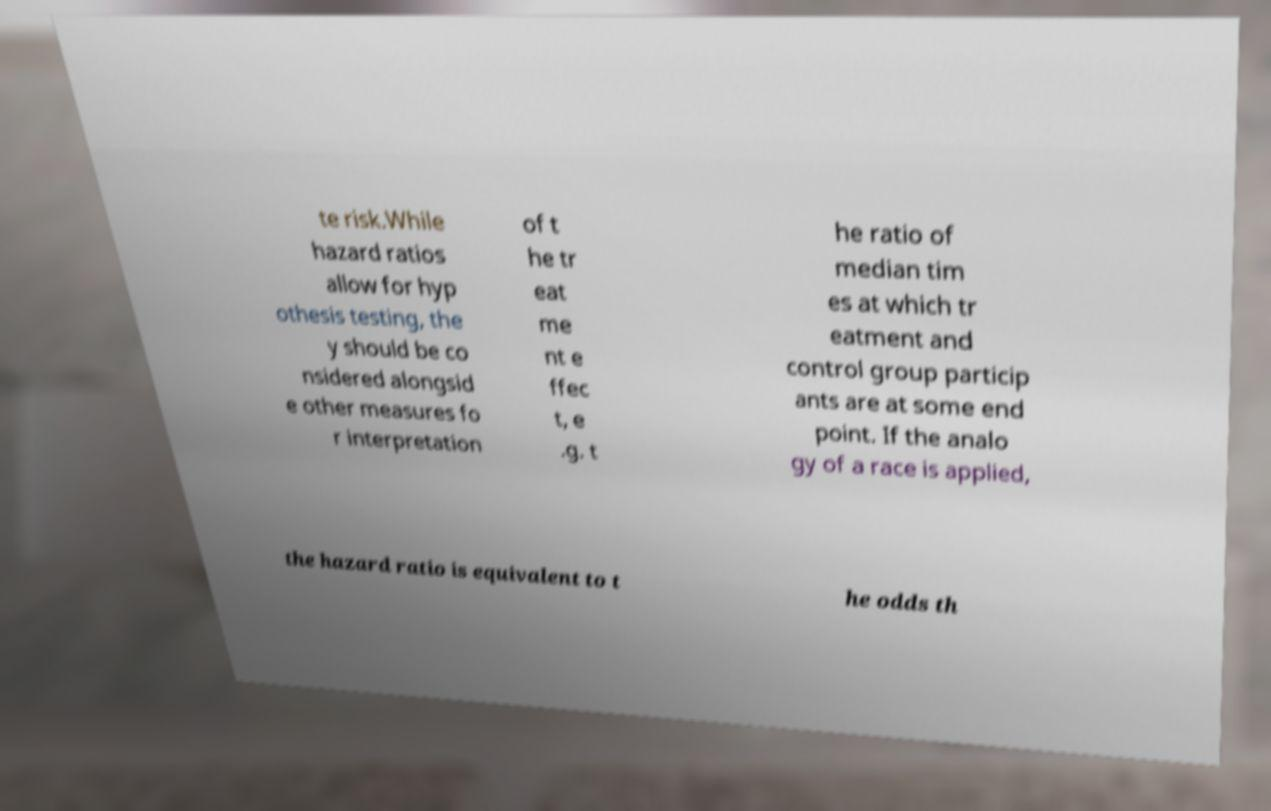Can you accurately transcribe the text from the provided image for me? te risk.While hazard ratios allow for hyp othesis testing, the y should be co nsidered alongsid e other measures fo r interpretation of t he tr eat me nt e ffec t, e .g. t he ratio of median tim es at which tr eatment and control group particip ants are at some end point. If the analo gy of a race is applied, the hazard ratio is equivalent to t he odds th 